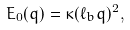Convert formula to latex. <formula><loc_0><loc_0><loc_500><loc_500>E _ { 0 } ( { q } ) = \kappa ( \ell _ { b } q ) ^ { 2 } ,</formula> 